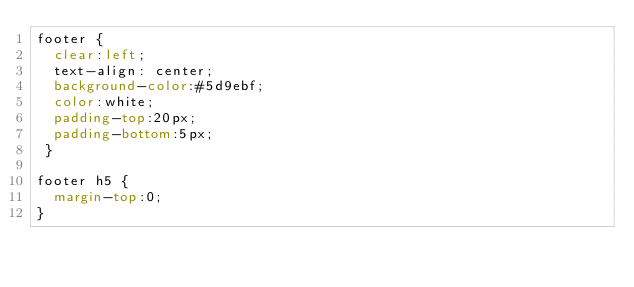Convert code to text. <code><loc_0><loc_0><loc_500><loc_500><_CSS_>footer {
	clear:left;
	text-align: center;
	background-color:#5d9ebf;
	color:white;
	padding-top:20px;
	padding-bottom:5px;
 }

footer h5 {
	margin-top:0;
}</code> 